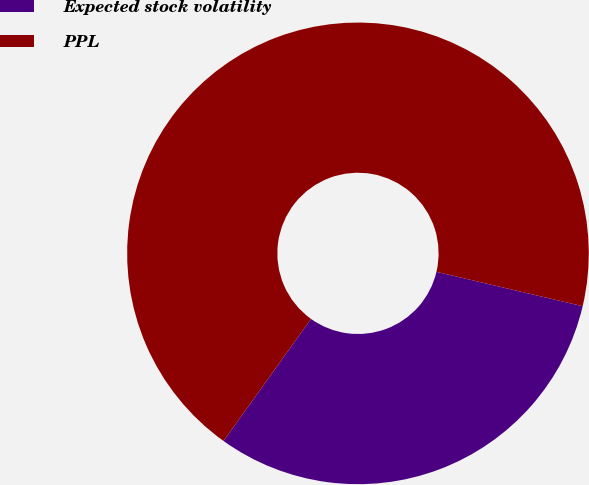Convert chart. <chart><loc_0><loc_0><loc_500><loc_500><pie_chart><fcel>Expected stock volatility<fcel>PPL<nl><fcel>31.22%<fcel>68.78%<nl></chart> 